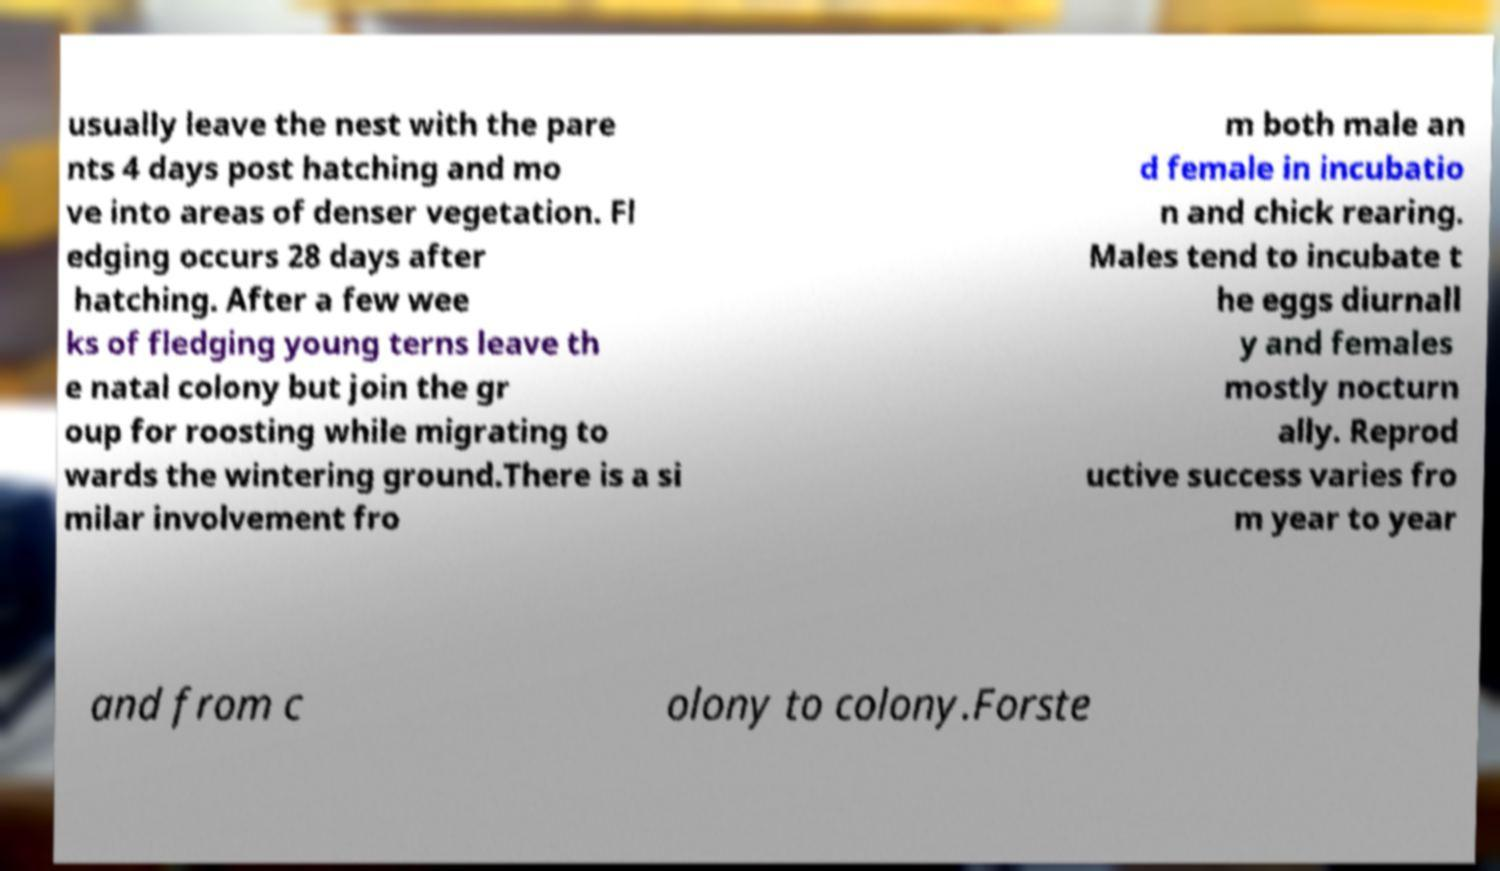There's text embedded in this image that I need extracted. Can you transcribe it verbatim? usually leave the nest with the pare nts 4 days post hatching and mo ve into areas of denser vegetation. Fl edging occurs 28 days after hatching. After a few wee ks of fledging young terns leave th e natal colony but join the gr oup for roosting while migrating to wards the wintering ground.There is a si milar involvement fro m both male an d female in incubatio n and chick rearing. Males tend to incubate t he eggs diurnall y and females mostly nocturn ally. Reprod uctive success varies fro m year to year and from c olony to colony.Forste 